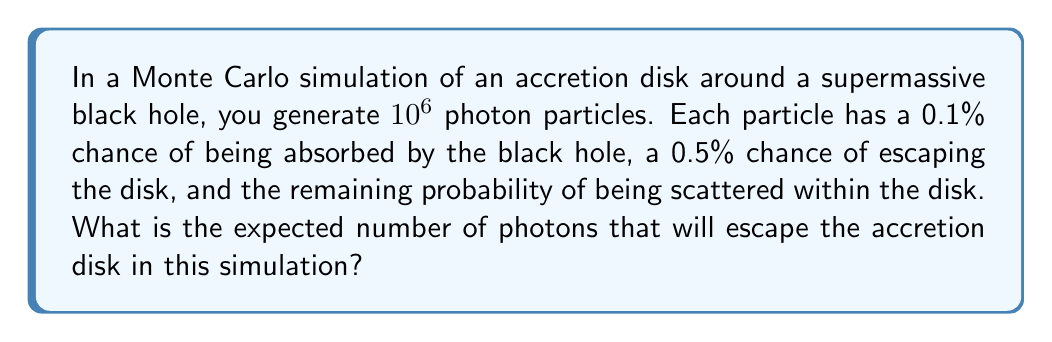Give your solution to this math problem. To solve this problem, we'll follow these steps:

1) First, let's identify the probability of a photon escaping the disk:
   $p(\text{escape}) = 0.5\% = 0.005$

2) In a Monte Carlo simulation, the expected number of events is equal to the number of trials multiplied by the probability of the event occurring in a single trial.

3) In this case:
   - Number of trials (photons) = $10^6$
   - Probability of escape = $0.005$

4) The expected number of escaping photons is:

   $$E(\text{escaping photons}) = 10^6 \times 0.005 = 5000$$

5) Therefore, we expect 5000 photons to escape the accretion disk in this simulation.

Note: This simple model assumes each photon's fate is independent and doesn't account for the complex physics of real accretion disks. In actual research, you would use more sophisticated models that consider factors like the disk's temperature profile, opacity, and the black hole's spin.
Answer: 5000 photons 